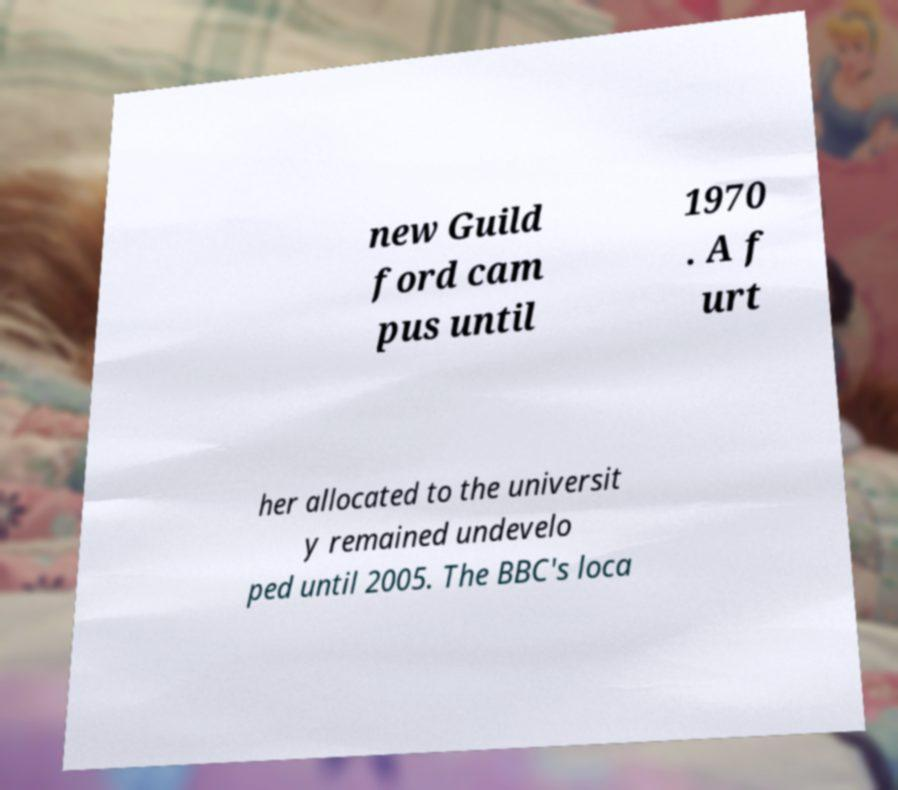Could you assist in decoding the text presented in this image and type it out clearly? new Guild ford cam pus until 1970 . A f urt her allocated to the universit y remained undevelo ped until 2005. The BBC's loca 